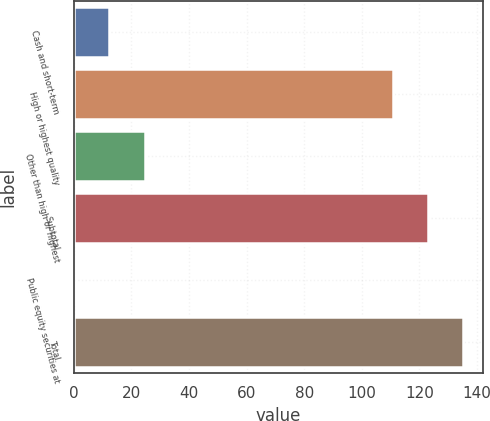Convert chart to OTSL. <chart><loc_0><loc_0><loc_500><loc_500><bar_chart><fcel>Cash and short-term<fcel>High or highest quality<fcel>Other than high or highest<fcel>Subtotal<fcel>Public equity securities at<fcel>Total<nl><fcel>12.33<fcel>110.7<fcel>24.56<fcel>122.93<fcel>0.1<fcel>135.16<nl></chart> 